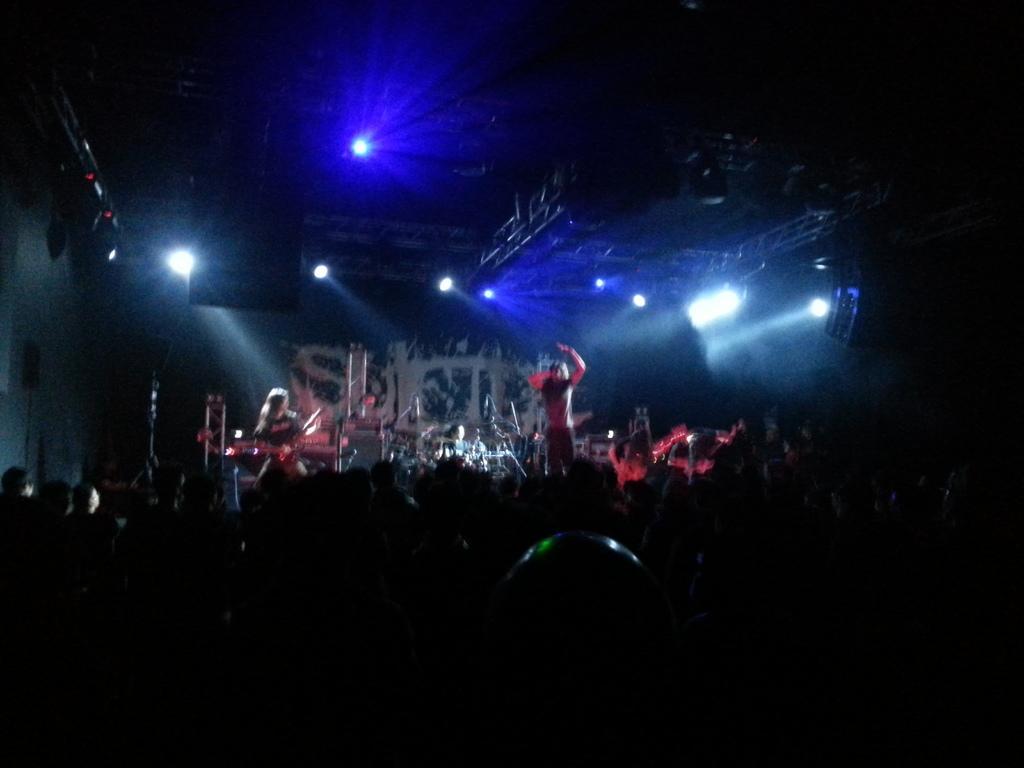How would you summarize this image in a sentence or two? In the center of the image, we can see two people on the stage and one of them is playing music. In the background, there are musical instruments and we can see a crowd. At the top, there are lights, cameras and rods and there is a wall. 